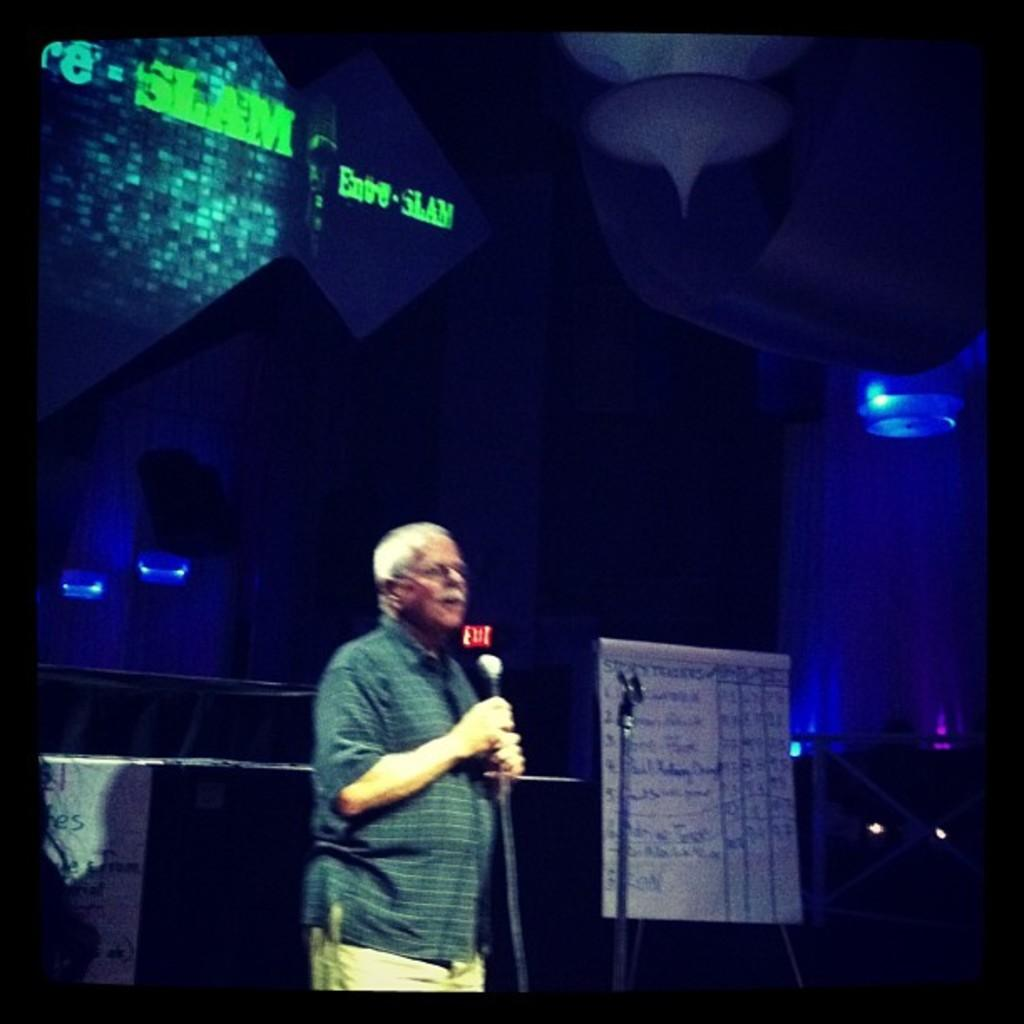What is the person in the image holding? The person is holding a mic in the image. What can be seen in the image besides the person holding the mic? There is a stand and a white sheet visible in the image. What can be seen in the background of the image? There are lights and a screen visible in the background of the image. What type of polish is being applied to the shelf in the image? There is no shelf or polish present in the image. 